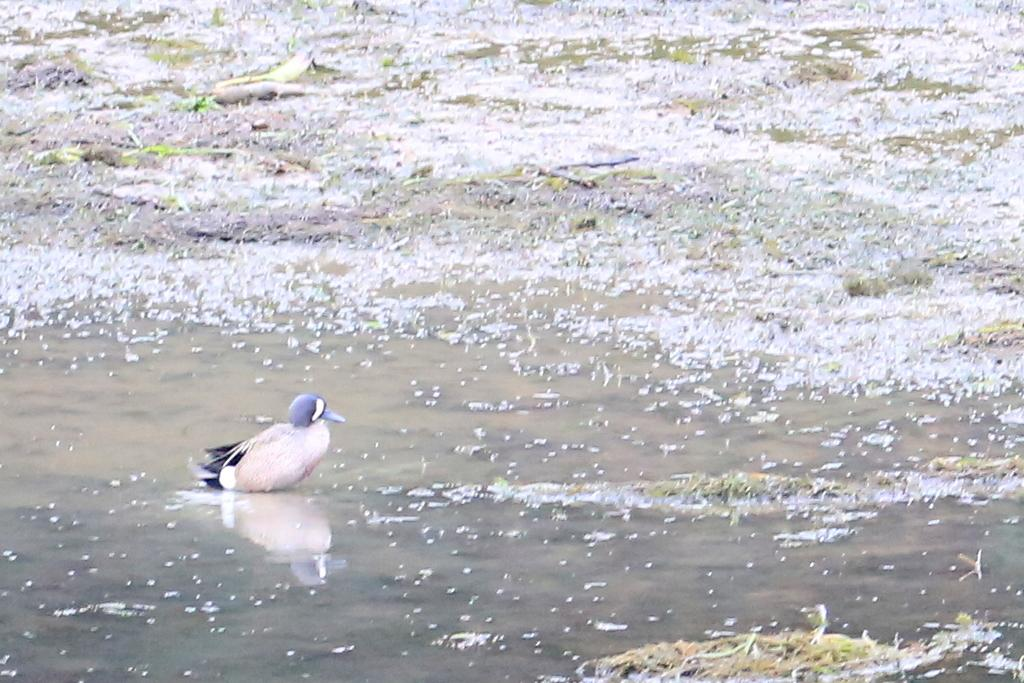What type of animal is in the water in the image? There is a bird in the water in the image. What type of vegetation can be seen in the image? There is grass visible in the image. What is the primary element in which the bird is situated? The bird is situated in water. What type of poison is the bird using to catch fish in the image? There is no indication in the image that the bird is using any type of poison to catch fish. Can you tell me how many kittens are playing with the bird in the image? There are no kittens present in the image. 